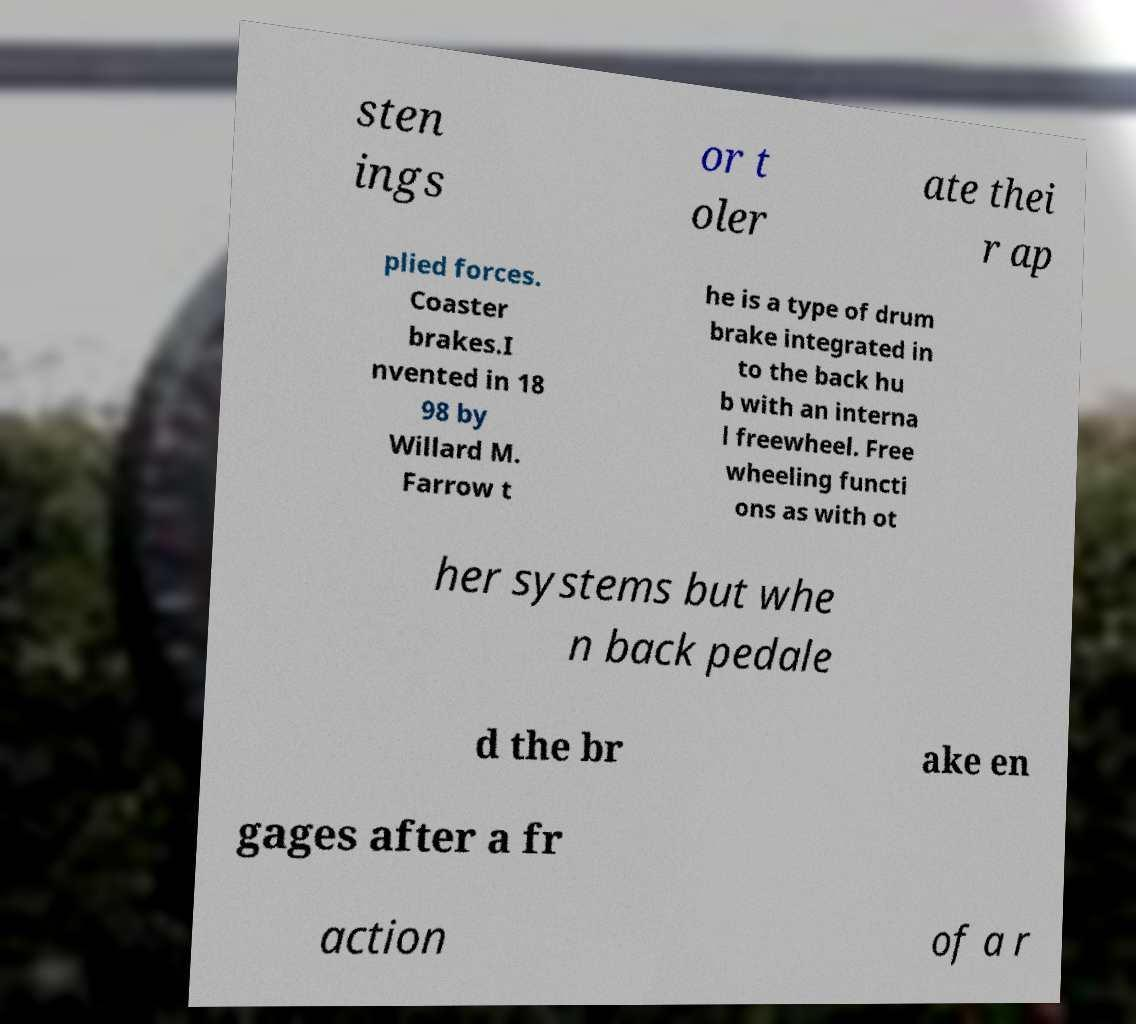Please identify and transcribe the text found in this image. sten ings or t oler ate thei r ap plied forces. Coaster brakes.I nvented in 18 98 by Willard M. Farrow t he is a type of drum brake integrated in to the back hu b with an interna l freewheel. Free wheeling functi ons as with ot her systems but whe n back pedale d the br ake en gages after a fr action of a r 